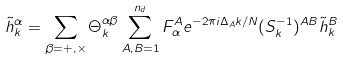Convert formula to latex. <formula><loc_0><loc_0><loc_500><loc_500>\tilde { h } _ { k } ^ { \alpha } = \sum _ { \beta = + , \times } \Theta ^ { \alpha \beta } _ { k } \sum _ { A , B = 1 } ^ { n _ { d } } F ^ { A } _ { \alpha } e ^ { - 2 \pi i \Delta _ { A } k / N } ( { S } ^ { - 1 } _ { k } ) ^ { A B } \tilde { h } ^ { B } _ { k }</formula> 